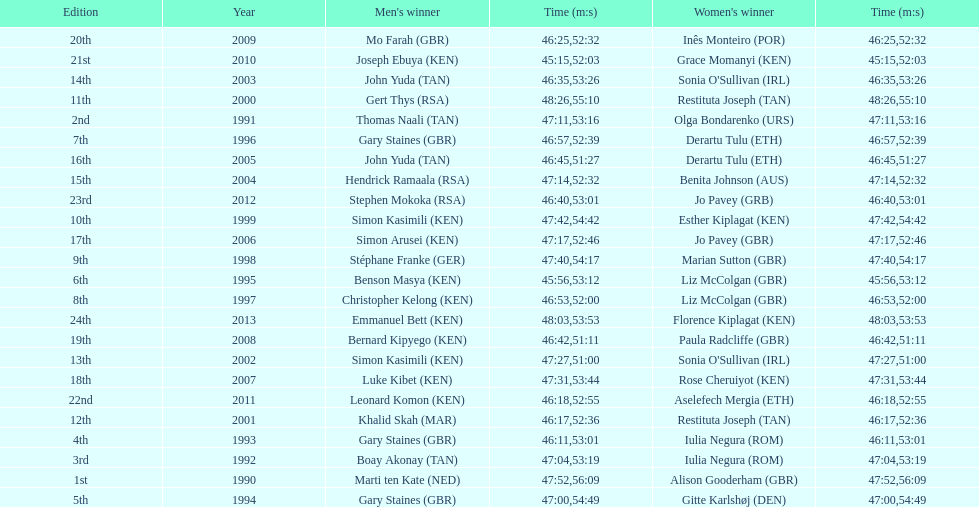For the 2013 bupa great south run, what are the differences in finishing times between men's and women's categories? 5:50. 